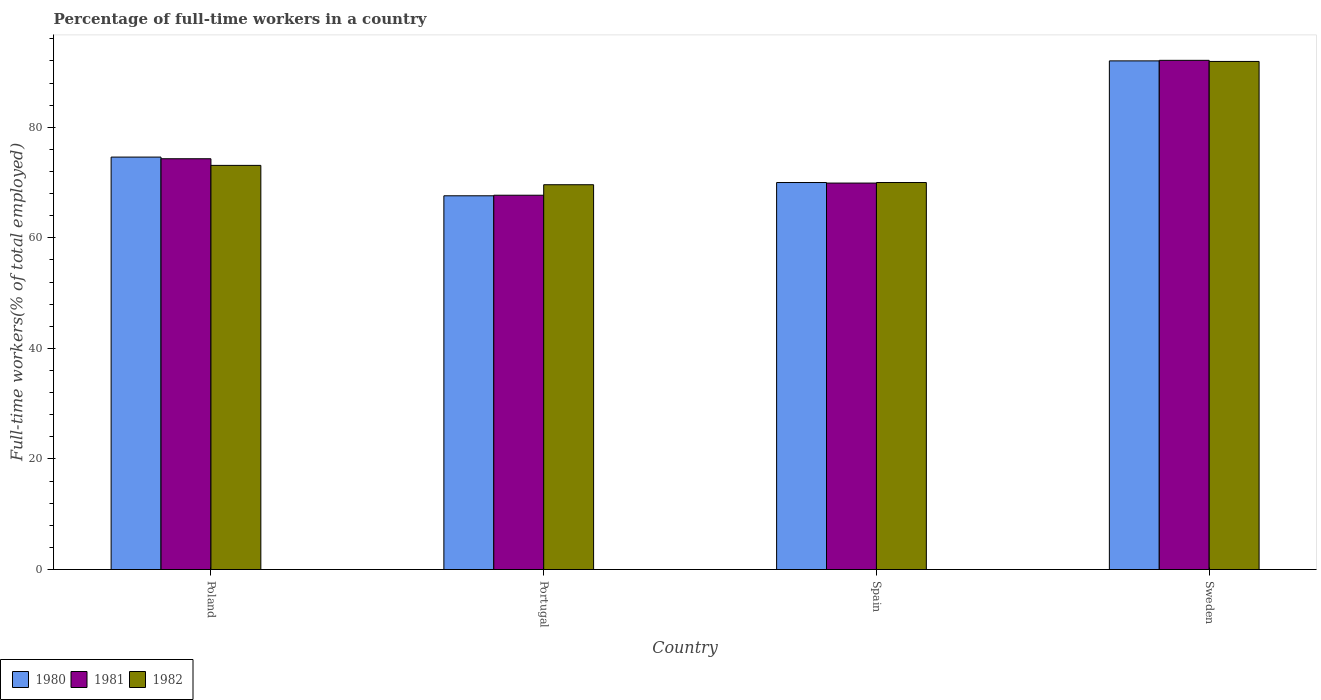How many different coloured bars are there?
Make the answer very short. 3. How many groups of bars are there?
Your response must be concise. 4. How many bars are there on the 1st tick from the left?
Your response must be concise. 3. How many bars are there on the 1st tick from the right?
Provide a short and direct response. 3. What is the label of the 2nd group of bars from the left?
Offer a very short reply. Portugal. In how many cases, is the number of bars for a given country not equal to the number of legend labels?
Offer a terse response. 0. What is the percentage of full-time workers in 1981 in Portugal?
Ensure brevity in your answer.  67.7. Across all countries, what is the maximum percentage of full-time workers in 1981?
Your answer should be very brief. 92.1. Across all countries, what is the minimum percentage of full-time workers in 1982?
Give a very brief answer. 69.6. In which country was the percentage of full-time workers in 1982 minimum?
Your answer should be very brief. Portugal. What is the total percentage of full-time workers in 1980 in the graph?
Give a very brief answer. 304.2. What is the difference between the percentage of full-time workers in 1982 in Poland and that in Portugal?
Give a very brief answer. 3.5. What is the difference between the percentage of full-time workers in 1981 in Portugal and the percentage of full-time workers in 1980 in Poland?
Provide a succinct answer. -6.9. What is the average percentage of full-time workers in 1980 per country?
Offer a very short reply. 76.05. What is the difference between the percentage of full-time workers of/in 1980 and percentage of full-time workers of/in 1982 in Portugal?
Provide a short and direct response. -2. In how many countries, is the percentage of full-time workers in 1982 greater than 64 %?
Ensure brevity in your answer.  4. What is the ratio of the percentage of full-time workers in 1980 in Poland to that in Portugal?
Make the answer very short. 1.1. Is the difference between the percentage of full-time workers in 1980 in Portugal and Spain greater than the difference between the percentage of full-time workers in 1982 in Portugal and Spain?
Your answer should be very brief. No. What is the difference between the highest and the second highest percentage of full-time workers in 1982?
Give a very brief answer. -18.8. What is the difference between the highest and the lowest percentage of full-time workers in 1981?
Your answer should be compact. 24.4. In how many countries, is the percentage of full-time workers in 1980 greater than the average percentage of full-time workers in 1980 taken over all countries?
Ensure brevity in your answer.  1. What does the 3rd bar from the right in Poland represents?
Offer a terse response. 1980. Is it the case that in every country, the sum of the percentage of full-time workers in 1980 and percentage of full-time workers in 1982 is greater than the percentage of full-time workers in 1981?
Your answer should be very brief. Yes. How many bars are there?
Provide a succinct answer. 12. Are all the bars in the graph horizontal?
Keep it short and to the point. No. What is the difference between two consecutive major ticks on the Y-axis?
Your response must be concise. 20. Does the graph contain grids?
Your response must be concise. No. How are the legend labels stacked?
Offer a terse response. Horizontal. What is the title of the graph?
Make the answer very short. Percentage of full-time workers in a country. What is the label or title of the Y-axis?
Ensure brevity in your answer.  Full-time workers(% of total employed). What is the Full-time workers(% of total employed) in 1980 in Poland?
Provide a short and direct response. 74.6. What is the Full-time workers(% of total employed) of 1981 in Poland?
Provide a short and direct response. 74.3. What is the Full-time workers(% of total employed) of 1982 in Poland?
Give a very brief answer. 73.1. What is the Full-time workers(% of total employed) in 1980 in Portugal?
Provide a succinct answer. 67.6. What is the Full-time workers(% of total employed) in 1981 in Portugal?
Offer a very short reply. 67.7. What is the Full-time workers(% of total employed) of 1982 in Portugal?
Make the answer very short. 69.6. What is the Full-time workers(% of total employed) of 1981 in Spain?
Make the answer very short. 69.9. What is the Full-time workers(% of total employed) of 1982 in Spain?
Your answer should be very brief. 70. What is the Full-time workers(% of total employed) of 1980 in Sweden?
Give a very brief answer. 92. What is the Full-time workers(% of total employed) in 1981 in Sweden?
Offer a very short reply. 92.1. What is the Full-time workers(% of total employed) of 1982 in Sweden?
Make the answer very short. 91.9. Across all countries, what is the maximum Full-time workers(% of total employed) of 1980?
Ensure brevity in your answer.  92. Across all countries, what is the maximum Full-time workers(% of total employed) in 1981?
Your answer should be very brief. 92.1. Across all countries, what is the maximum Full-time workers(% of total employed) of 1982?
Provide a succinct answer. 91.9. Across all countries, what is the minimum Full-time workers(% of total employed) in 1980?
Provide a succinct answer. 67.6. Across all countries, what is the minimum Full-time workers(% of total employed) in 1981?
Offer a very short reply. 67.7. Across all countries, what is the minimum Full-time workers(% of total employed) in 1982?
Make the answer very short. 69.6. What is the total Full-time workers(% of total employed) in 1980 in the graph?
Offer a very short reply. 304.2. What is the total Full-time workers(% of total employed) in 1981 in the graph?
Your response must be concise. 304. What is the total Full-time workers(% of total employed) of 1982 in the graph?
Your answer should be very brief. 304.6. What is the difference between the Full-time workers(% of total employed) in 1980 in Poland and that in Portugal?
Your answer should be very brief. 7. What is the difference between the Full-time workers(% of total employed) of 1982 in Poland and that in Portugal?
Offer a very short reply. 3.5. What is the difference between the Full-time workers(% of total employed) in 1980 in Poland and that in Spain?
Provide a short and direct response. 4.6. What is the difference between the Full-time workers(% of total employed) in 1980 in Poland and that in Sweden?
Ensure brevity in your answer.  -17.4. What is the difference between the Full-time workers(% of total employed) of 1981 in Poland and that in Sweden?
Your answer should be very brief. -17.8. What is the difference between the Full-time workers(% of total employed) of 1982 in Poland and that in Sweden?
Your response must be concise. -18.8. What is the difference between the Full-time workers(% of total employed) of 1981 in Portugal and that in Spain?
Provide a short and direct response. -2.2. What is the difference between the Full-time workers(% of total employed) in 1980 in Portugal and that in Sweden?
Your response must be concise. -24.4. What is the difference between the Full-time workers(% of total employed) in 1981 in Portugal and that in Sweden?
Your answer should be very brief. -24.4. What is the difference between the Full-time workers(% of total employed) in 1982 in Portugal and that in Sweden?
Your answer should be very brief. -22.3. What is the difference between the Full-time workers(% of total employed) in 1980 in Spain and that in Sweden?
Your answer should be compact. -22. What is the difference between the Full-time workers(% of total employed) of 1981 in Spain and that in Sweden?
Keep it short and to the point. -22.2. What is the difference between the Full-time workers(% of total employed) of 1982 in Spain and that in Sweden?
Provide a short and direct response. -21.9. What is the difference between the Full-time workers(% of total employed) of 1980 in Poland and the Full-time workers(% of total employed) of 1981 in Portugal?
Provide a short and direct response. 6.9. What is the difference between the Full-time workers(% of total employed) in 1980 in Poland and the Full-time workers(% of total employed) in 1981 in Spain?
Offer a very short reply. 4.7. What is the difference between the Full-time workers(% of total employed) of 1981 in Poland and the Full-time workers(% of total employed) of 1982 in Spain?
Offer a very short reply. 4.3. What is the difference between the Full-time workers(% of total employed) of 1980 in Poland and the Full-time workers(% of total employed) of 1981 in Sweden?
Give a very brief answer. -17.5. What is the difference between the Full-time workers(% of total employed) in 1980 in Poland and the Full-time workers(% of total employed) in 1982 in Sweden?
Your answer should be very brief. -17.3. What is the difference between the Full-time workers(% of total employed) of 1981 in Poland and the Full-time workers(% of total employed) of 1982 in Sweden?
Your response must be concise. -17.6. What is the difference between the Full-time workers(% of total employed) of 1980 in Portugal and the Full-time workers(% of total employed) of 1982 in Spain?
Offer a very short reply. -2.4. What is the difference between the Full-time workers(% of total employed) in 1981 in Portugal and the Full-time workers(% of total employed) in 1982 in Spain?
Provide a short and direct response. -2.3. What is the difference between the Full-time workers(% of total employed) of 1980 in Portugal and the Full-time workers(% of total employed) of 1981 in Sweden?
Provide a succinct answer. -24.5. What is the difference between the Full-time workers(% of total employed) in 1980 in Portugal and the Full-time workers(% of total employed) in 1982 in Sweden?
Your response must be concise. -24.3. What is the difference between the Full-time workers(% of total employed) of 1981 in Portugal and the Full-time workers(% of total employed) of 1982 in Sweden?
Give a very brief answer. -24.2. What is the difference between the Full-time workers(% of total employed) in 1980 in Spain and the Full-time workers(% of total employed) in 1981 in Sweden?
Give a very brief answer. -22.1. What is the difference between the Full-time workers(% of total employed) of 1980 in Spain and the Full-time workers(% of total employed) of 1982 in Sweden?
Ensure brevity in your answer.  -21.9. What is the average Full-time workers(% of total employed) in 1980 per country?
Give a very brief answer. 76.05. What is the average Full-time workers(% of total employed) of 1982 per country?
Make the answer very short. 76.15. What is the difference between the Full-time workers(% of total employed) in 1980 and Full-time workers(% of total employed) in 1981 in Poland?
Provide a succinct answer. 0.3. What is the difference between the Full-time workers(% of total employed) in 1980 and Full-time workers(% of total employed) in 1981 in Portugal?
Ensure brevity in your answer.  -0.1. What is the difference between the Full-time workers(% of total employed) of 1980 and Full-time workers(% of total employed) of 1982 in Portugal?
Your answer should be compact. -2. What is the difference between the Full-time workers(% of total employed) in 1981 and Full-time workers(% of total employed) in 1982 in Portugal?
Offer a terse response. -1.9. What is the difference between the Full-time workers(% of total employed) in 1980 and Full-time workers(% of total employed) in 1982 in Spain?
Your response must be concise. 0. What is the difference between the Full-time workers(% of total employed) of 1981 and Full-time workers(% of total employed) of 1982 in Spain?
Your answer should be very brief. -0.1. What is the difference between the Full-time workers(% of total employed) in 1980 and Full-time workers(% of total employed) in 1982 in Sweden?
Provide a short and direct response. 0.1. What is the ratio of the Full-time workers(% of total employed) in 1980 in Poland to that in Portugal?
Keep it short and to the point. 1.1. What is the ratio of the Full-time workers(% of total employed) in 1981 in Poland to that in Portugal?
Make the answer very short. 1.1. What is the ratio of the Full-time workers(% of total employed) of 1982 in Poland to that in Portugal?
Your response must be concise. 1.05. What is the ratio of the Full-time workers(% of total employed) in 1980 in Poland to that in Spain?
Provide a short and direct response. 1.07. What is the ratio of the Full-time workers(% of total employed) of 1981 in Poland to that in Spain?
Give a very brief answer. 1.06. What is the ratio of the Full-time workers(% of total employed) of 1982 in Poland to that in Spain?
Your response must be concise. 1.04. What is the ratio of the Full-time workers(% of total employed) of 1980 in Poland to that in Sweden?
Your response must be concise. 0.81. What is the ratio of the Full-time workers(% of total employed) in 1981 in Poland to that in Sweden?
Make the answer very short. 0.81. What is the ratio of the Full-time workers(% of total employed) in 1982 in Poland to that in Sweden?
Your response must be concise. 0.8. What is the ratio of the Full-time workers(% of total employed) of 1980 in Portugal to that in Spain?
Provide a short and direct response. 0.97. What is the ratio of the Full-time workers(% of total employed) of 1981 in Portugal to that in Spain?
Your answer should be very brief. 0.97. What is the ratio of the Full-time workers(% of total employed) of 1980 in Portugal to that in Sweden?
Provide a succinct answer. 0.73. What is the ratio of the Full-time workers(% of total employed) in 1981 in Portugal to that in Sweden?
Offer a terse response. 0.74. What is the ratio of the Full-time workers(% of total employed) in 1982 in Portugal to that in Sweden?
Offer a very short reply. 0.76. What is the ratio of the Full-time workers(% of total employed) in 1980 in Spain to that in Sweden?
Ensure brevity in your answer.  0.76. What is the ratio of the Full-time workers(% of total employed) in 1981 in Spain to that in Sweden?
Make the answer very short. 0.76. What is the ratio of the Full-time workers(% of total employed) in 1982 in Spain to that in Sweden?
Your response must be concise. 0.76. What is the difference between the highest and the second highest Full-time workers(% of total employed) in 1981?
Keep it short and to the point. 17.8. What is the difference between the highest and the second highest Full-time workers(% of total employed) of 1982?
Provide a succinct answer. 18.8. What is the difference between the highest and the lowest Full-time workers(% of total employed) of 1980?
Provide a succinct answer. 24.4. What is the difference between the highest and the lowest Full-time workers(% of total employed) in 1981?
Ensure brevity in your answer.  24.4. What is the difference between the highest and the lowest Full-time workers(% of total employed) of 1982?
Your response must be concise. 22.3. 